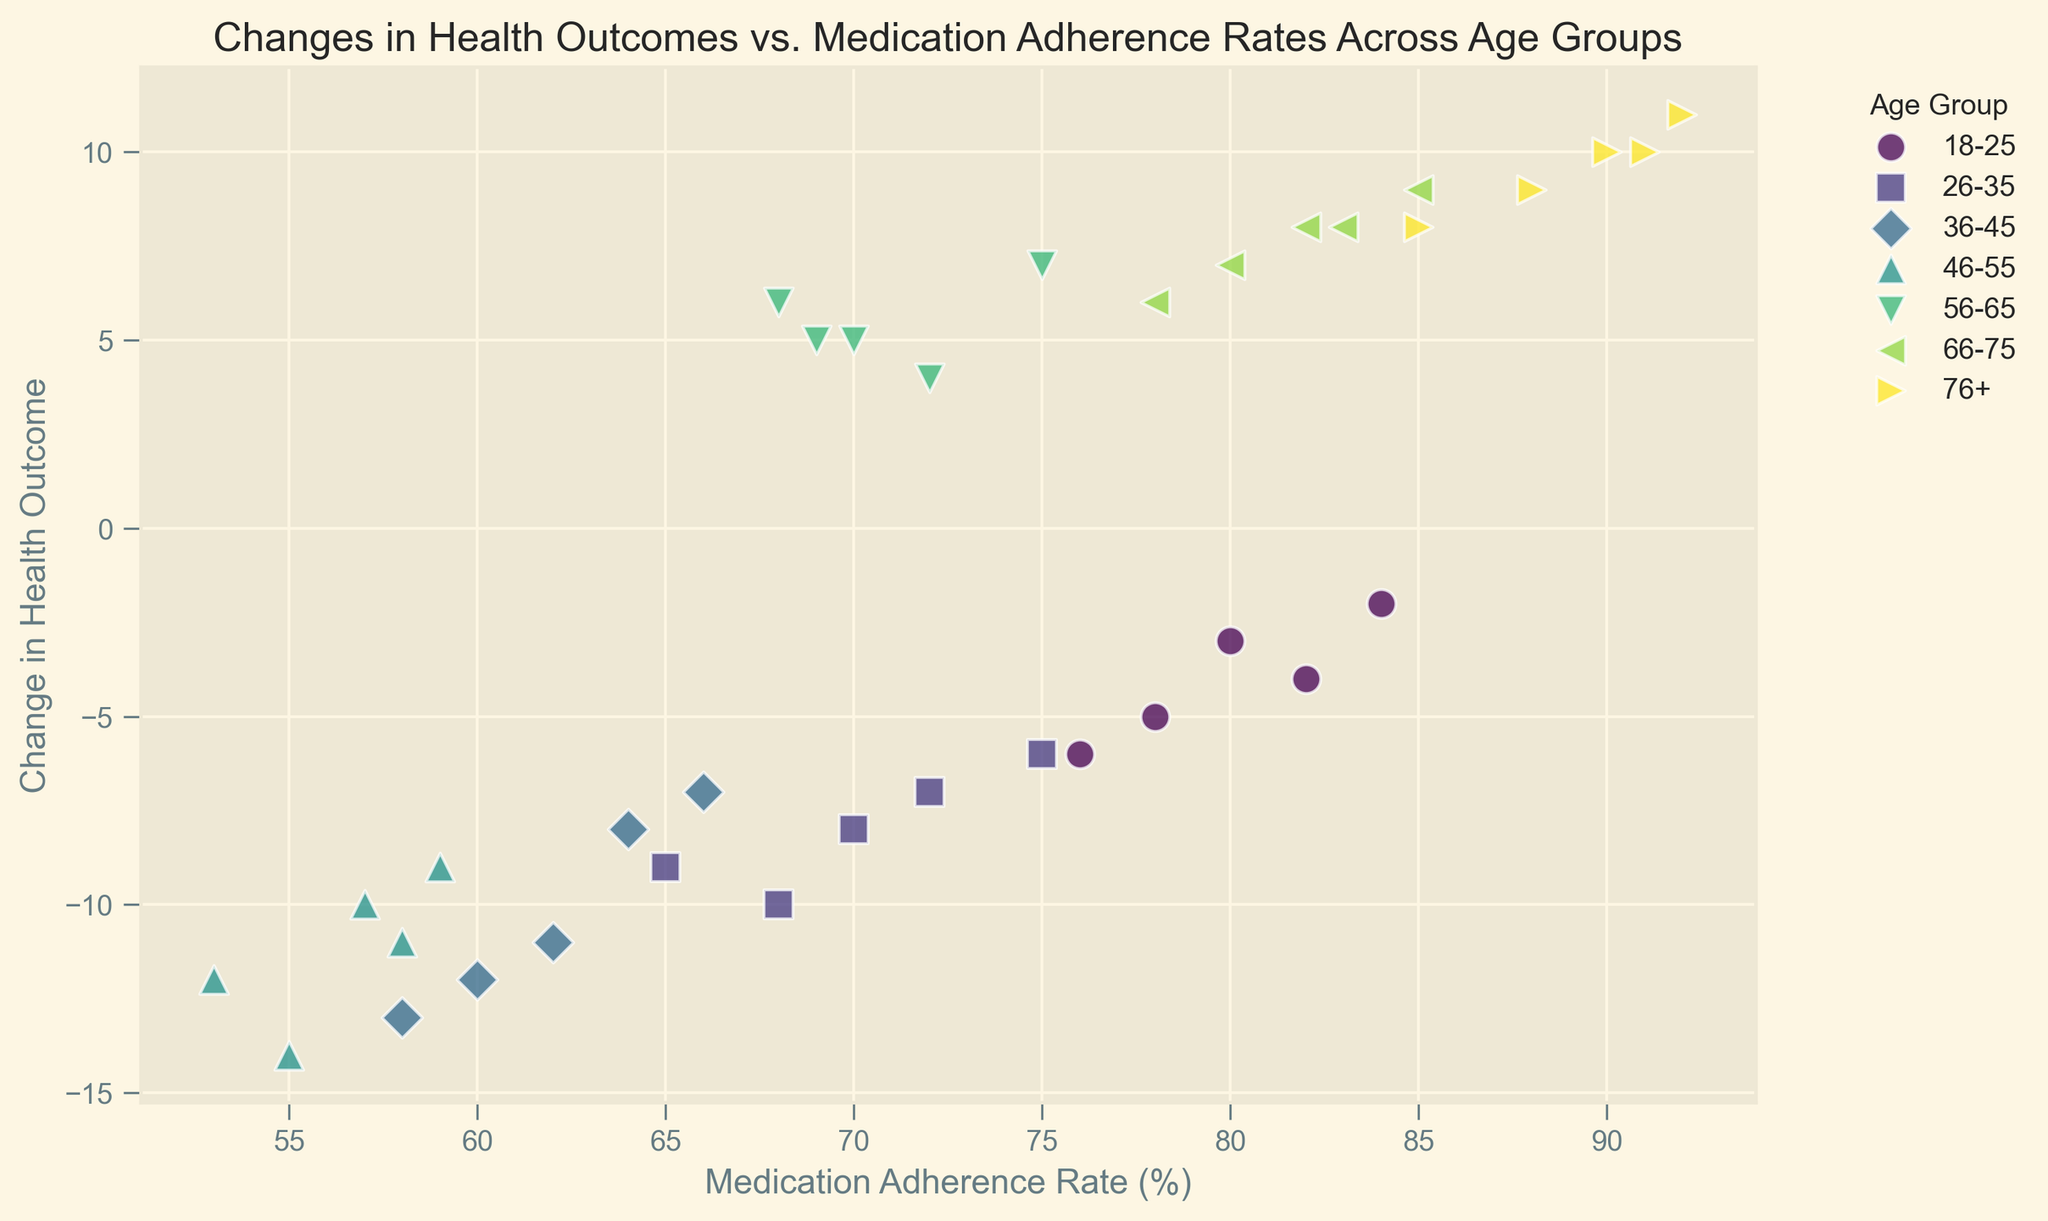What's the overall trend between medication adherence rate and change in health outcome? By examining the scatter plot, we observe that as medication adherence rates increase, the change in health outcomes tends to improve. Higher adherence rates correlate with less negative or more positive health outcomes.
Answer: As adherence rates increase, health outcomes improve Which age group has the highest medication adherence rate and what is their corresponding change in health outcome? By looking at the scatter plot, we can identify the age group 76+ with adherence rates between 85% and 92%. Their corresponding changes in health outcomes are all positive, ranging from 8 to 11.
Answer: 76+; change in health outcome is between 8 and 11 How does the change in health outcome for the age group 46-55 compare to the age group 56-65? By comparing the scatter points, it's clear that the 46-55 age group has negative changes in health outcomes (-14 to -9), while the 56-65 age group has positive changes (4 to 7).
Answer: 46-55: negative (-14 to -9); 56-65: positive (4 to 7) What is the median medication adherence rate for the age group 18-25 and what is the corresponding median change in health outcome? To find the median, we list the adherence rates (76, 78, 80, 82, 84) and take the middle value, which is 80. The corresponding changes in health outcome are (-6, -5, -4, -3, -2), so the median change is -4.
Answer: Median adherence rate: 80%; Median change in health outcome: -4 Compare the adherence rates and changes in health outcomes for the age groups 26-35 and 66-75. Which age group demonstrates better overall outcomes? The 26-35 age group has adherence rates between 65% and 75%, with changes in health outcomes ranging from -10 to -6 (all negative). The 66-75 age group has adherence rates between 78% and 85%, with positive changes in health outcomes (6 to 9).
Answer: 66-75 demonstrates better overall outcomes with positive changes Which age group shows the widest range of change in health outcomes, and what is that range? Observing the scatter plot, the 36-45 age group has changes in health outcomes from -13 to -7, giving them a range of 6. No other group shows a wider range.
Answer: 36-45; range of 6 What's the average change in health outcome for the 56-65 age group? Summing the changes in health outcomes for 56-65 (5, 4, 6, 7, 5) gives us 27, and dividing by the 5 data points results in an average change of 5.4.
Answer: 5.4 Based on the scatter plot, which age group seems to benefit the least from medication adherence? The 46-55 age group, displaying the highest adherence rates but the most negative changes in health outcomes consistently. This suggests less benefit from adherence rates.
Answer: 46-55 